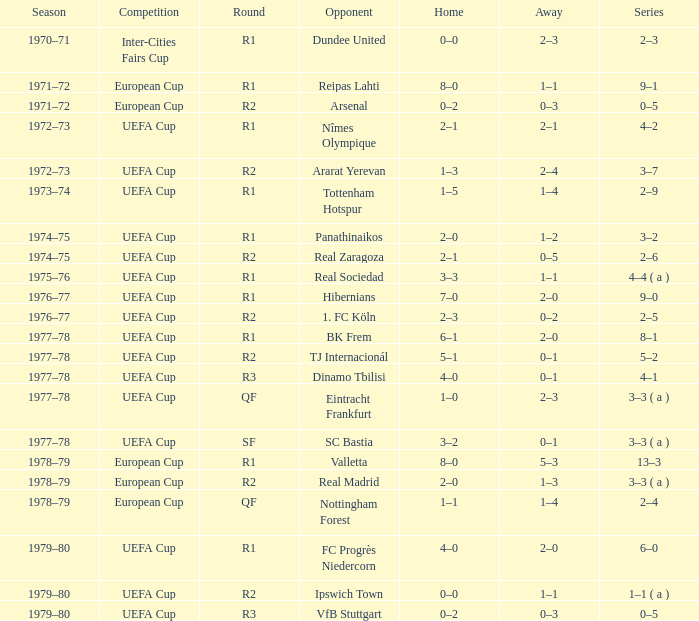Which Round has a Competition of uefa cup, and a Series of 5–2? R2. 